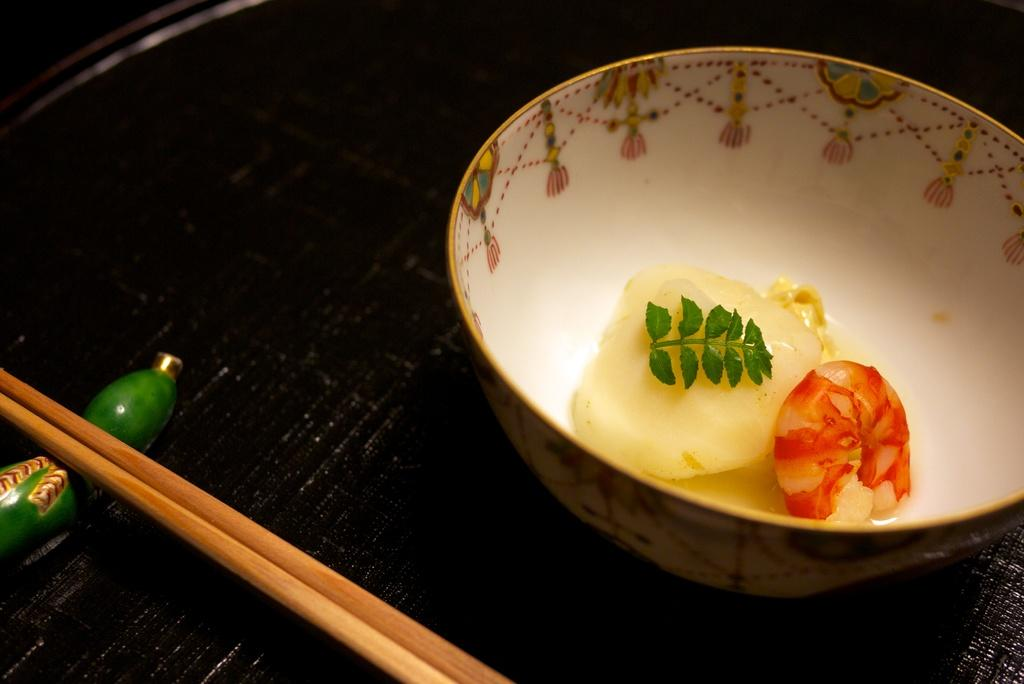What is the main object in the center of the image? There is a table in the middle of the image. What is located on the top right side of the table? There is a bowl with food in the top right side of the image. What utensil is present on the bottom left side of the table? Chopsticks are present in the bottom left side of the image. How much wealth is displayed on the table in the image? There is no indication of wealth in the image; it features a table with a bowl of food and chopsticks. What type of bucket can be seen on the table in the image? There is no bucket present on the table in the image. 